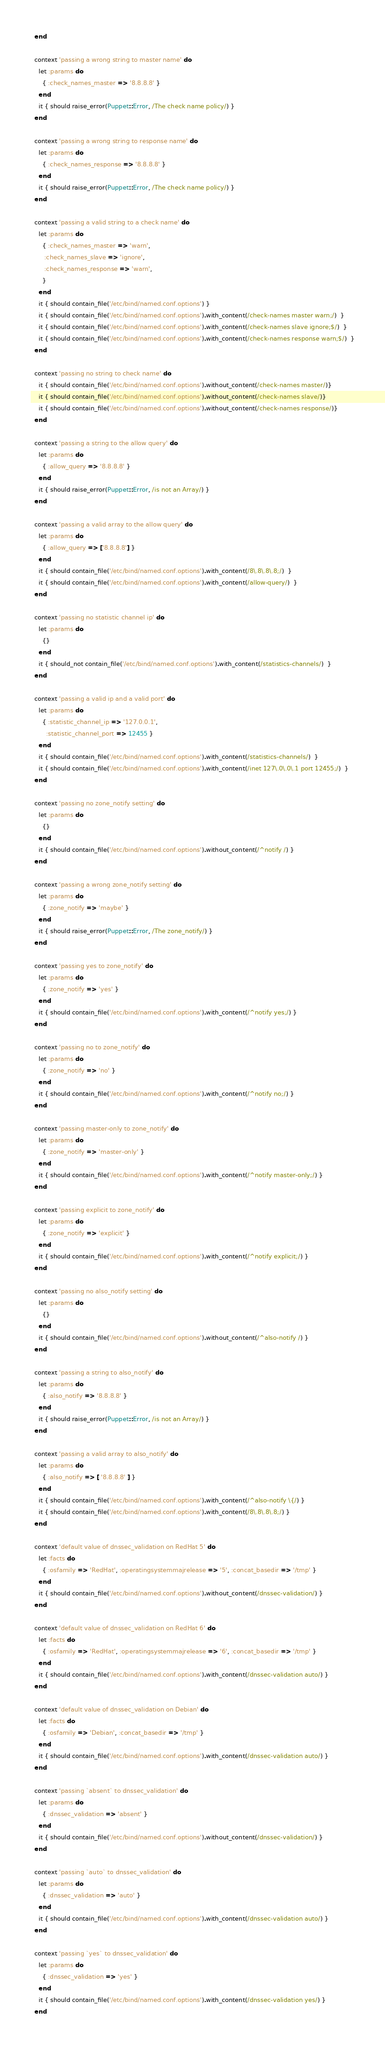<code> <loc_0><loc_0><loc_500><loc_500><_Ruby_>  end

  context 'passing a wrong string to master name' do
    let :params do
      { :check_names_master => '8.8.8.8' }
    end
    it { should raise_error(Puppet::Error, /The check name policy/) }
  end

  context 'passing a wrong string to response name' do
    let :params do
      { :check_names_response => '8.8.8.8' }
    end
    it { should raise_error(Puppet::Error, /The check name policy/) }
  end

  context 'passing a valid string to a check name' do
    let :params do
      { :check_names_master => 'warn',
       :check_names_slave => 'ignore',
       :check_names_response => 'warn',
      }
    end
    it { should contain_file('/etc/bind/named.conf.options') }
    it { should contain_file('/etc/bind/named.conf.options').with_content(/check-names master warn;/)  }
    it { should contain_file('/etc/bind/named.conf.options').with_content(/check-names slave ignore;$/)  }
    it { should contain_file('/etc/bind/named.conf.options').with_content(/check-names response warn;$/)  }
  end

  context 'passing no string to check name' do
    it { should contain_file('/etc/bind/named.conf.options').without_content(/check-names master/)}
    it { should contain_file('/etc/bind/named.conf.options').without_content(/check-names slave/)}
    it { should contain_file('/etc/bind/named.conf.options').without_content(/check-names response/)}
  end

  context 'passing a string to the allow query' do
    let :params do
      { :allow_query => '8.8.8.8' }
    end
    it { should raise_error(Puppet::Error, /is not an Array/) }
  end

  context 'passing a valid array to the allow query' do
    let :params do
      { :allow_query => ['8.8.8.8'] }
    end
    it { should contain_file('/etc/bind/named.conf.options').with_content(/8\.8\.8\.8;/)  }
    it { should contain_file('/etc/bind/named.conf.options').with_content(/allow-query/)  }
  end

  context 'passing no statistic channel ip' do
    let :params do
      {}
    end
    it { should_not contain_file('/etc/bind/named.conf.options').with_content(/statistics-channels/)  }
  end

  context 'passing a valid ip and a valid port' do
    let :params do
      { :statistic_channel_ip => '127.0.0.1',
        :statistic_channel_port => 12455 }
    end
    it { should contain_file('/etc/bind/named.conf.options').with_content(/statistics-channels/)  }
    it { should contain_file('/etc/bind/named.conf.options').with_content(/inet 127\.0\.0\.1 port 12455;/)  }
  end

  context 'passing no zone_notify setting' do
    let :params do
      {}
    end
    it { should contain_file('/etc/bind/named.conf.options').without_content(/^notify /) }
  end

  context 'passing a wrong zone_notify setting' do
    let :params do
      { :zone_notify => 'maybe' }
    end
    it { should raise_error(Puppet::Error, /The zone_notify/) }
  end

  context 'passing yes to zone_notify' do
    let :params do
      { :zone_notify => 'yes' }
    end
    it { should contain_file('/etc/bind/named.conf.options').with_content(/^notify yes;/) }
  end

  context 'passing no to zone_notify' do
    let :params do
      { :zone_notify => 'no' }
    end
    it { should contain_file('/etc/bind/named.conf.options').with_content(/^notify no;/) }
  end

  context 'passing master-only to zone_notify' do
    let :params do
      { :zone_notify => 'master-only' }
    end
    it { should contain_file('/etc/bind/named.conf.options').with_content(/^notify master-only;/) }
  end

  context 'passing explicit to zone_notify' do
    let :params do
      { :zone_notify => 'explicit' }
    end
    it { should contain_file('/etc/bind/named.conf.options').with_content(/^notify explicit;/) }
  end

  context 'passing no also_notify setting' do
    let :params do
      {}
    end
    it { should contain_file('/etc/bind/named.conf.options').without_content(/^also-notify /) }
  end

  context 'passing a string to also_notify' do
    let :params do
      { :also_notify => '8.8.8.8' }
    end
    it { should raise_error(Puppet::Error, /is not an Array/) }
  end

  context 'passing a valid array to also_notify' do
    let :params do
      { :also_notify => [ '8.8.8.8' ] }
    end
    it { should contain_file('/etc/bind/named.conf.options').with_content(/^also-notify \{/) }
    it { should contain_file('/etc/bind/named.conf.options').with_content(/8\.8\.8\.8;/) }
  end

  context 'default value of dnssec_validation on RedHat 5' do
    let :facts do
      { :osfamily => 'RedHat', :operatingsystemmajrelease => '5', :concat_basedir => '/tmp' }
    end
    it { should contain_file('/etc/bind/named.conf.options').without_content(/dnssec-validation/) }
  end

  context 'default value of dnssec_validation on RedHat 6' do
    let :facts do
      { :osfamily => 'RedHat', :operatingsystemmajrelease => '6', :concat_basedir => '/tmp' }
    end
    it { should contain_file('/etc/bind/named.conf.options').with_content(/dnssec-validation auto/) }
  end

  context 'default value of dnssec_validation on Debian' do
    let :facts do
      { :osfamily => 'Debian', :concat_basedir => '/tmp' }
    end
    it { should contain_file('/etc/bind/named.conf.options').with_content(/dnssec-validation auto/) }
  end

  context 'passing `absent` to dnssec_validation' do
    let :params do
      { :dnssec_validation => 'absent' }
    end
    it { should contain_file('/etc/bind/named.conf.options').without_content(/dnssec-validation/) }
  end

  context 'passing `auto` to dnssec_validation' do
    let :params do
      { :dnssec_validation => 'auto' }
    end
    it { should contain_file('/etc/bind/named.conf.options').with_content(/dnssec-validation auto/) }
  end

  context 'passing `yes` to dnssec_validation' do
    let :params do
      { :dnssec_validation => 'yes' }
    end
    it { should contain_file('/etc/bind/named.conf.options').with_content(/dnssec-validation yes/) }
  end
</code> 